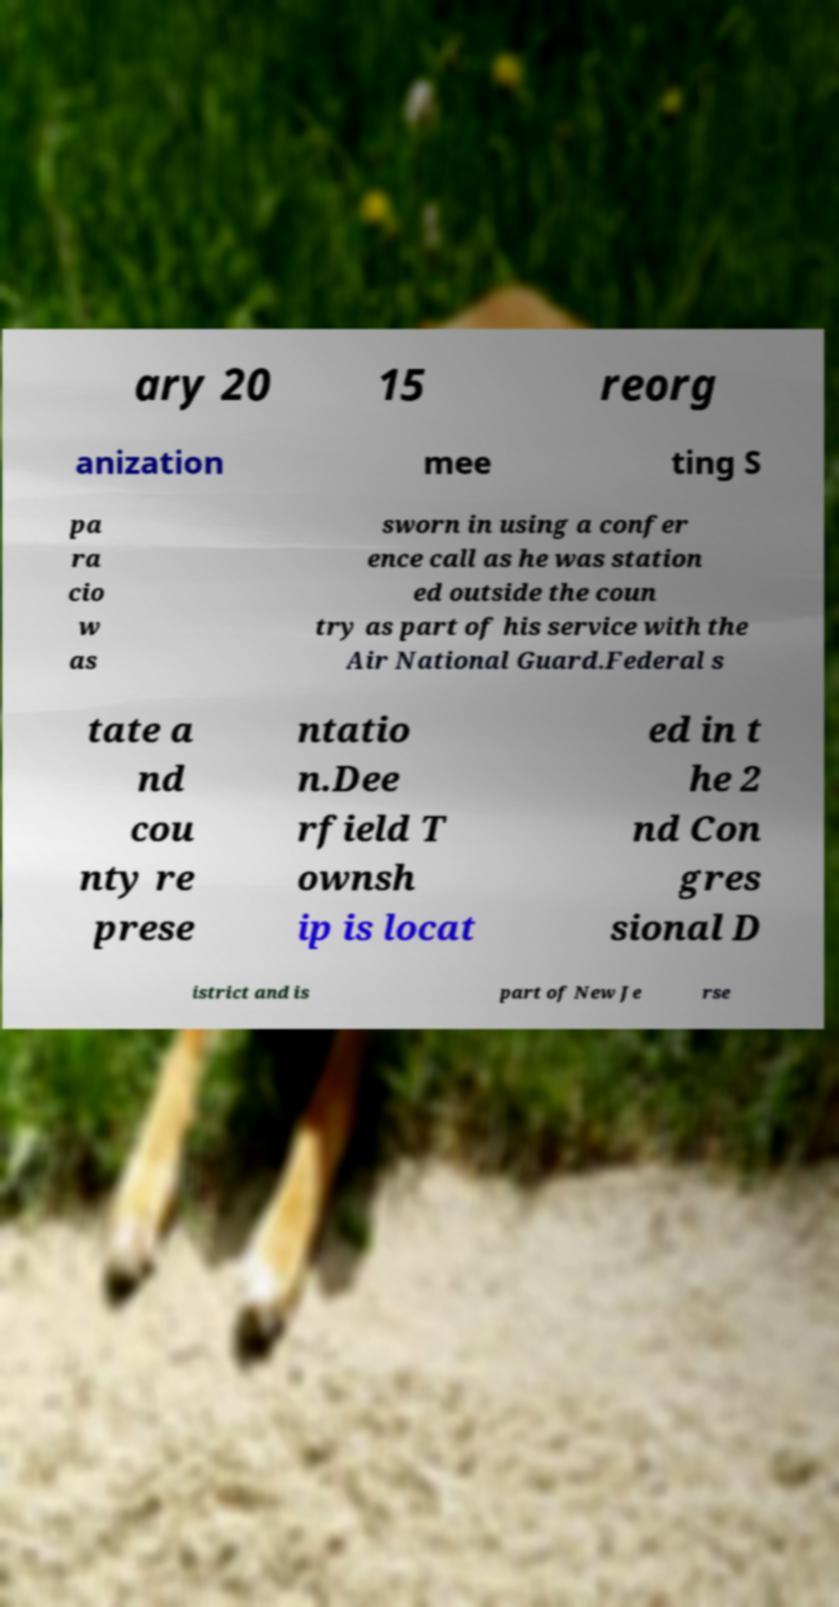I need the written content from this picture converted into text. Can you do that? ary 20 15 reorg anization mee ting S pa ra cio w as sworn in using a confer ence call as he was station ed outside the coun try as part of his service with the Air National Guard.Federal s tate a nd cou nty re prese ntatio n.Dee rfield T ownsh ip is locat ed in t he 2 nd Con gres sional D istrict and is part of New Je rse 